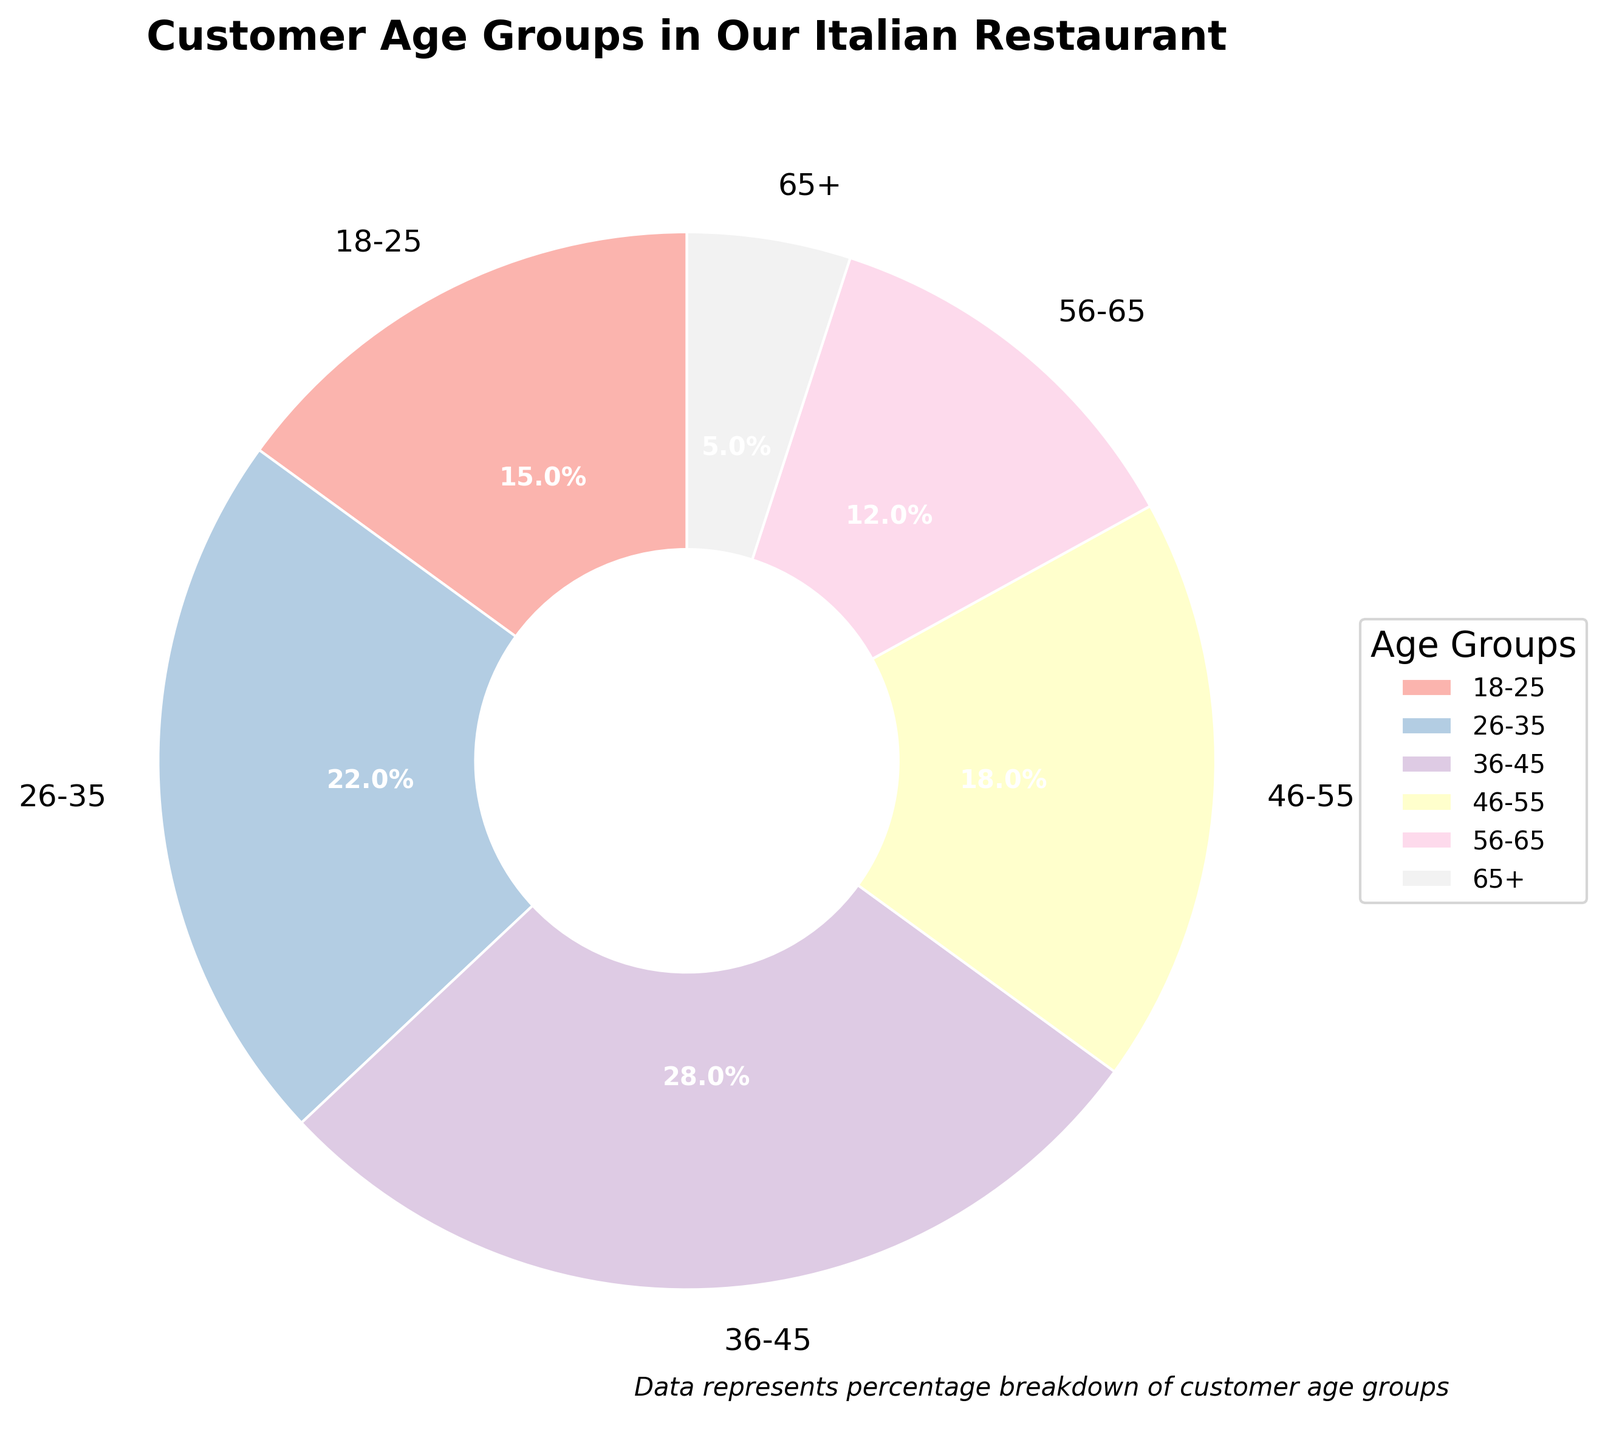What is the age group with the highest percentage of customers? Observing the pie chart, the age group 36-45 occupies the largest segment, as indicated by its size and the label stating 28%.
Answer: 36-45 Which age group has fewer customers, 18-25 or 65+? The chart shows that the age group 65+ has 5%, while the age group 18-25 has 15%. Since 5% is less than 15%, the 65+ group has fewer customers.
Answer: 65+ What is the combined percentage of customers aged 18-25 and 26-35? Add the percentages of the 18-25 group (15%) and the 26-35 group (22%). So, 15% + 22% = 37%.
Answer: 37% Which age group contributes to nearly one-fifth of the customers? One-fifth of 100% is 20%. The pie chart shows that the 46-55 age group accounts for 18%, which is close to one-fifth.
Answer: 46-55 How much greater is the percentage of customers aged 36-45 compared to those aged 56-65? The percentage of the 36-45 age group is 28%, and the 56-65 group is 12%. The difference is 28% - 12% = 16%.
Answer: 16% Between which two age groups is the percentage difference exactly 6%? The 26-35 age group has 22%, and the 46-55 age group has 18%. The difference is 22% - 18% = 4%, so another check reveals the 18-25 age group with 15% and the 56-65 age group with 12% meeting this criteria (15% - 12% = 3%). This challenge reveals no exact 6%.
Answer: None Is the percentage of 36-45 customers closer to the combined percentage of 18-25 and 65+ or 26-35 and 56-65? Combined percentage of 18-25 (15%) and 65+ (5%) is 20%. Combined percentage of 26-35 (22%) and 56-65 (12%) is 34%. Since 28% (36-45) is closer to 34% than 20%, the answer is the combined percentage of 26-35 and 56-65.
Answer: 26-35 and 56-65 What is the sum percentage of customers aged 46-55, 56-65, and 65+? Add the percentages: 18% (46-55) + 12% (56-65) + 5% (65+) = 35%.
Answer: 35% Which age group segment is shown with the second most prominent color in the chart? The pie chart shows 36-45 as the largest; the next largest segment is 26-35, and visually, it’s represented by the second most prominent color.
Answer: 26-35 If the percentage of the 18-25 age group increased by 5%, what would be their new percentage? The current percentage is 15%. Increasing this by 5% results in 15% + 5% = 20%.
Answer: 20% If the combined percentage of customers aged 36-45 and 46-55 represents major customers, what percentage do they represent together? Add the percentages of 36-45 (28%) and 46-55 (18%). So, 28% + 18% = 46%.
Answer: 46% 